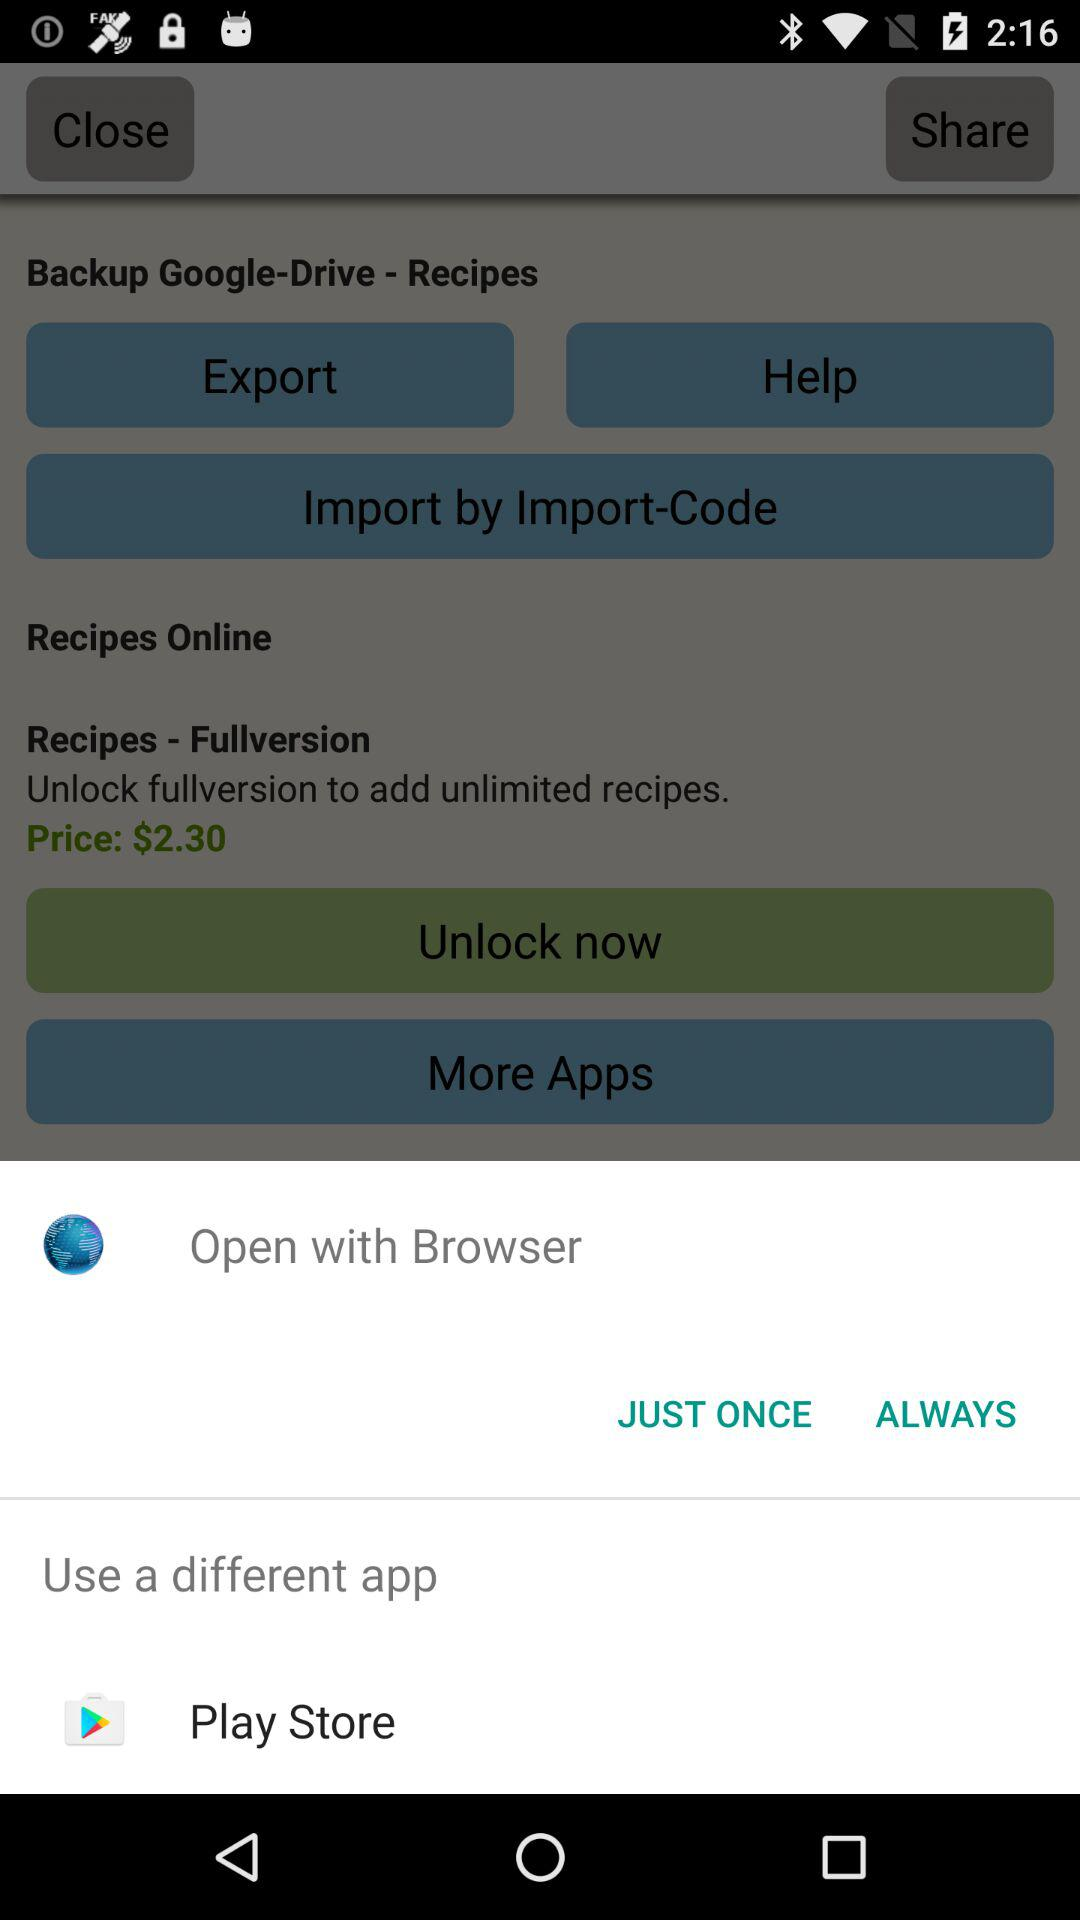What are the different applications we can use to open it? The different applications are: "Open with Browser", and "Play Store". 